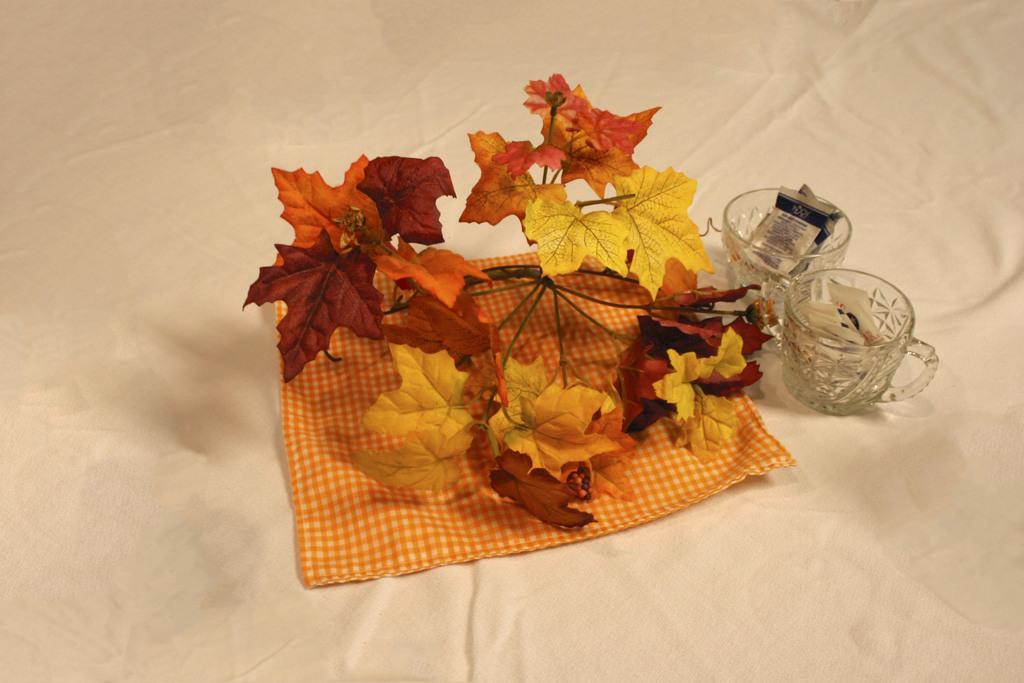Can you describe this image briefly? As we can see in the image there is a white color cloth, glasses and trees. 